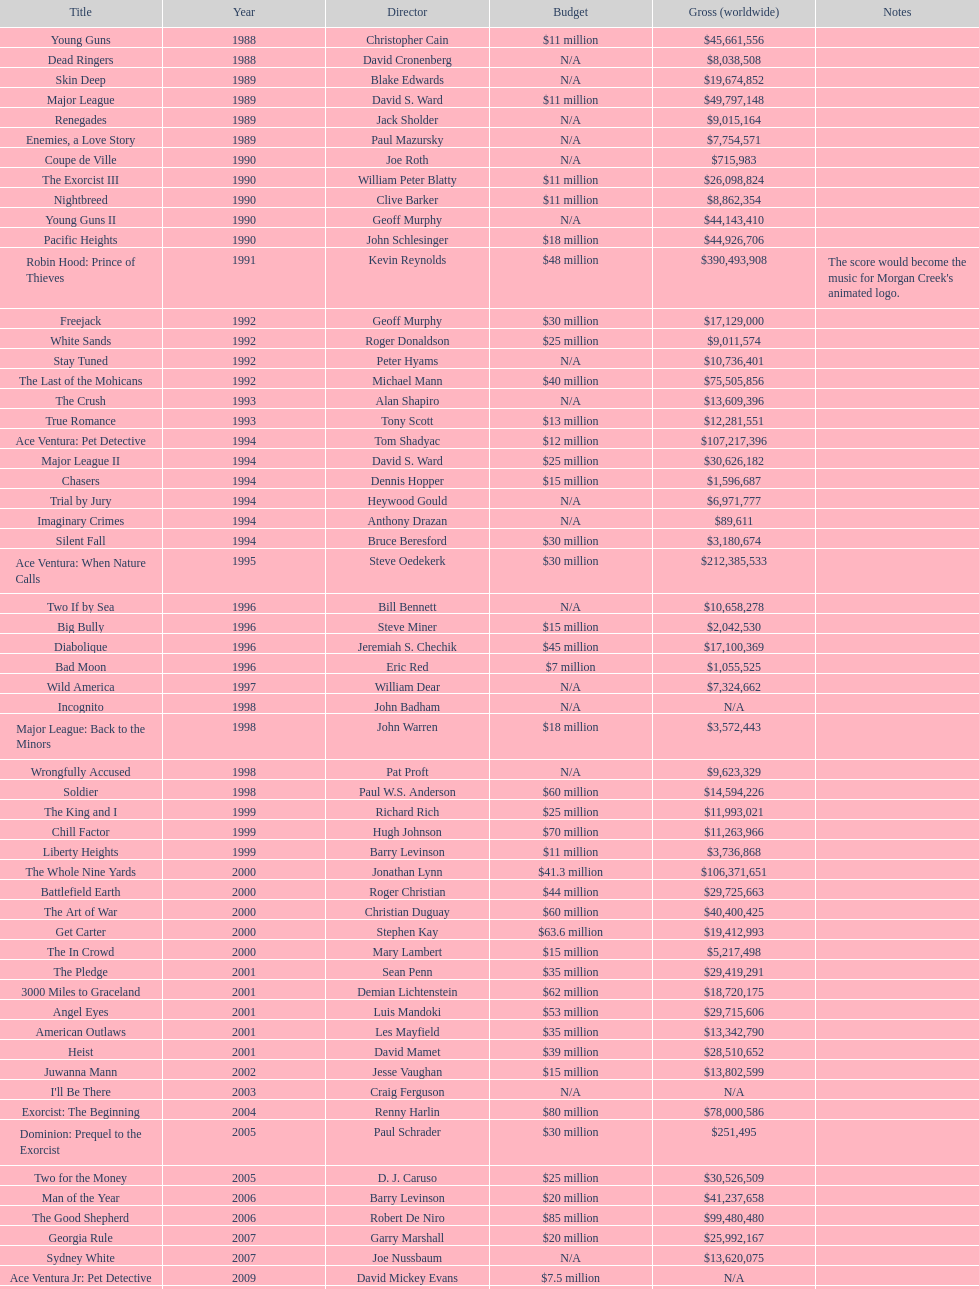What movie came out after bad moon? Wild America. Could you parse the entire table as a dict? {'header': ['Title', 'Year', 'Director', 'Budget', 'Gross (worldwide)', 'Notes'], 'rows': [['Young Guns', '1988', 'Christopher Cain', '$11 million', '$45,661,556', ''], ['Dead Ringers', '1988', 'David Cronenberg', 'N/A', '$8,038,508', ''], ['Skin Deep', '1989', 'Blake Edwards', 'N/A', '$19,674,852', ''], ['Major League', '1989', 'David S. Ward', '$11 million', '$49,797,148', ''], ['Renegades', '1989', 'Jack Sholder', 'N/A', '$9,015,164', ''], ['Enemies, a Love Story', '1989', 'Paul Mazursky', 'N/A', '$7,754,571', ''], ['Coupe de Ville', '1990', 'Joe Roth', 'N/A', '$715,983', ''], ['The Exorcist III', '1990', 'William Peter Blatty', '$11 million', '$26,098,824', ''], ['Nightbreed', '1990', 'Clive Barker', '$11 million', '$8,862,354', ''], ['Young Guns II', '1990', 'Geoff Murphy', 'N/A', '$44,143,410', ''], ['Pacific Heights', '1990', 'John Schlesinger', '$18 million', '$44,926,706', ''], ['Robin Hood: Prince of Thieves', '1991', 'Kevin Reynolds', '$48 million', '$390,493,908', "The score would become the music for Morgan Creek's animated logo."], ['Freejack', '1992', 'Geoff Murphy', '$30 million', '$17,129,000', ''], ['White Sands', '1992', 'Roger Donaldson', '$25 million', '$9,011,574', ''], ['Stay Tuned', '1992', 'Peter Hyams', 'N/A', '$10,736,401', ''], ['The Last of the Mohicans', '1992', 'Michael Mann', '$40 million', '$75,505,856', ''], ['The Crush', '1993', 'Alan Shapiro', 'N/A', '$13,609,396', ''], ['True Romance', '1993', 'Tony Scott', '$13 million', '$12,281,551', ''], ['Ace Ventura: Pet Detective', '1994', 'Tom Shadyac', '$12 million', '$107,217,396', ''], ['Major League II', '1994', 'David S. Ward', '$25 million', '$30,626,182', ''], ['Chasers', '1994', 'Dennis Hopper', '$15 million', '$1,596,687', ''], ['Trial by Jury', '1994', 'Heywood Gould', 'N/A', '$6,971,777', ''], ['Imaginary Crimes', '1994', 'Anthony Drazan', 'N/A', '$89,611', ''], ['Silent Fall', '1994', 'Bruce Beresford', '$30 million', '$3,180,674', ''], ['Ace Ventura: When Nature Calls', '1995', 'Steve Oedekerk', '$30 million', '$212,385,533', ''], ['Two If by Sea', '1996', 'Bill Bennett', 'N/A', '$10,658,278', ''], ['Big Bully', '1996', 'Steve Miner', '$15 million', '$2,042,530', ''], ['Diabolique', '1996', 'Jeremiah S. Chechik', '$45 million', '$17,100,369', ''], ['Bad Moon', '1996', 'Eric Red', '$7 million', '$1,055,525', ''], ['Wild America', '1997', 'William Dear', 'N/A', '$7,324,662', ''], ['Incognito', '1998', 'John Badham', 'N/A', 'N/A', ''], ['Major League: Back to the Minors', '1998', 'John Warren', '$18 million', '$3,572,443', ''], ['Wrongfully Accused', '1998', 'Pat Proft', 'N/A', '$9,623,329', ''], ['Soldier', '1998', 'Paul W.S. Anderson', '$60 million', '$14,594,226', ''], ['The King and I', '1999', 'Richard Rich', '$25 million', '$11,993,021', ''], ['Chill Factor', '1999', 'Hugh Johnson', '$70 million', '$11,263,966', ''], ['Liberty Heights', '1999', 'Barry Levinson', '$11 million', '$3,736,868', ''], ['The Whole Nine Yards', '2000', 'Jonathan Lynn', '$41.3 million', '$106,371,651', ''], ['Battlefield Earth', '2000', 'Roger Christian', '$44 million', '$29,725,663', ''], ['The Art of War', '2000', 'Christian Duguay', '$60 million', '$40,400,425', ''], ['Get Carter', '2000', 'Stephen Kay', '$63.6 million', '$19,412,993', ''], ['The In Crowd', '2000', 'Mary Lambert', '$15 million', '$5,217,498', ''], ['The Pledge', '2001', 'Sean Penn', '$35 million', '$29,419,291', ''], ['3000 Miles to Graceland', '2001', 'Demian Lichtenstein', '$62 million', '$18,720,175', ''], ['Angel Eyes', '2001', 'Luis Mandoki', '$53 million', '$29,715,606', ''], ['American Outlaws', '2001', 'Les Mayfield', '$35 million', '$13,342,790', ''], ['Heist', '2001', 'David Mamet', '$39 million', '$28,510,652', ''], ['Juwanna Mann', '2002', 'Jesse Vaughan', '$15 million', '$13,802,599', ''], ["I'll Be There", '2003', 'Craig Ferguson', 'N/A', 'N/A', ''], ['Exorcist: The Beginning', '2004', 'Renny Harlin', '$80 million', '$78,000,586', ''], ['Dominion: Prequel to the Exorcist', '2005', 'Paul Schrader', '$30 million', '$251,495', ''], ['Two for the Money', '2005', 'D. J. Caruso', '$25 million', '$30,526,509', ''], ['Man of the Year', '2006', 'Barry Levinson', '$20 million', '$41,237,658', ''], ['The Good Shepherd', '2006', 'Robert De Niro', '$85 million', '$99,480,480', ''], ['Georgia Rule', '2007', 'Garry Marshall', '$20 million', '$25,992,167', ''], ['Sydney White', '2007', 'Joe Nussbaum', 'N/A', '$13,620,075', ''], ['Ace Ventura Jr: Pet Detective', '2009', 'David Mickey Evans', '$7.5 million', 'N/A', ''], ['Dream House', '2011', 'Jim Sheridan', '$50 million', '$38,502,340', ''], ['The Thing', '2011', 'Matthijs van Heijningen Jr.', '$38 million', '$27,428,670', ''], ['Tupac', '2014', 'Antoine Fuqua', '$45 million', '', '']]} 